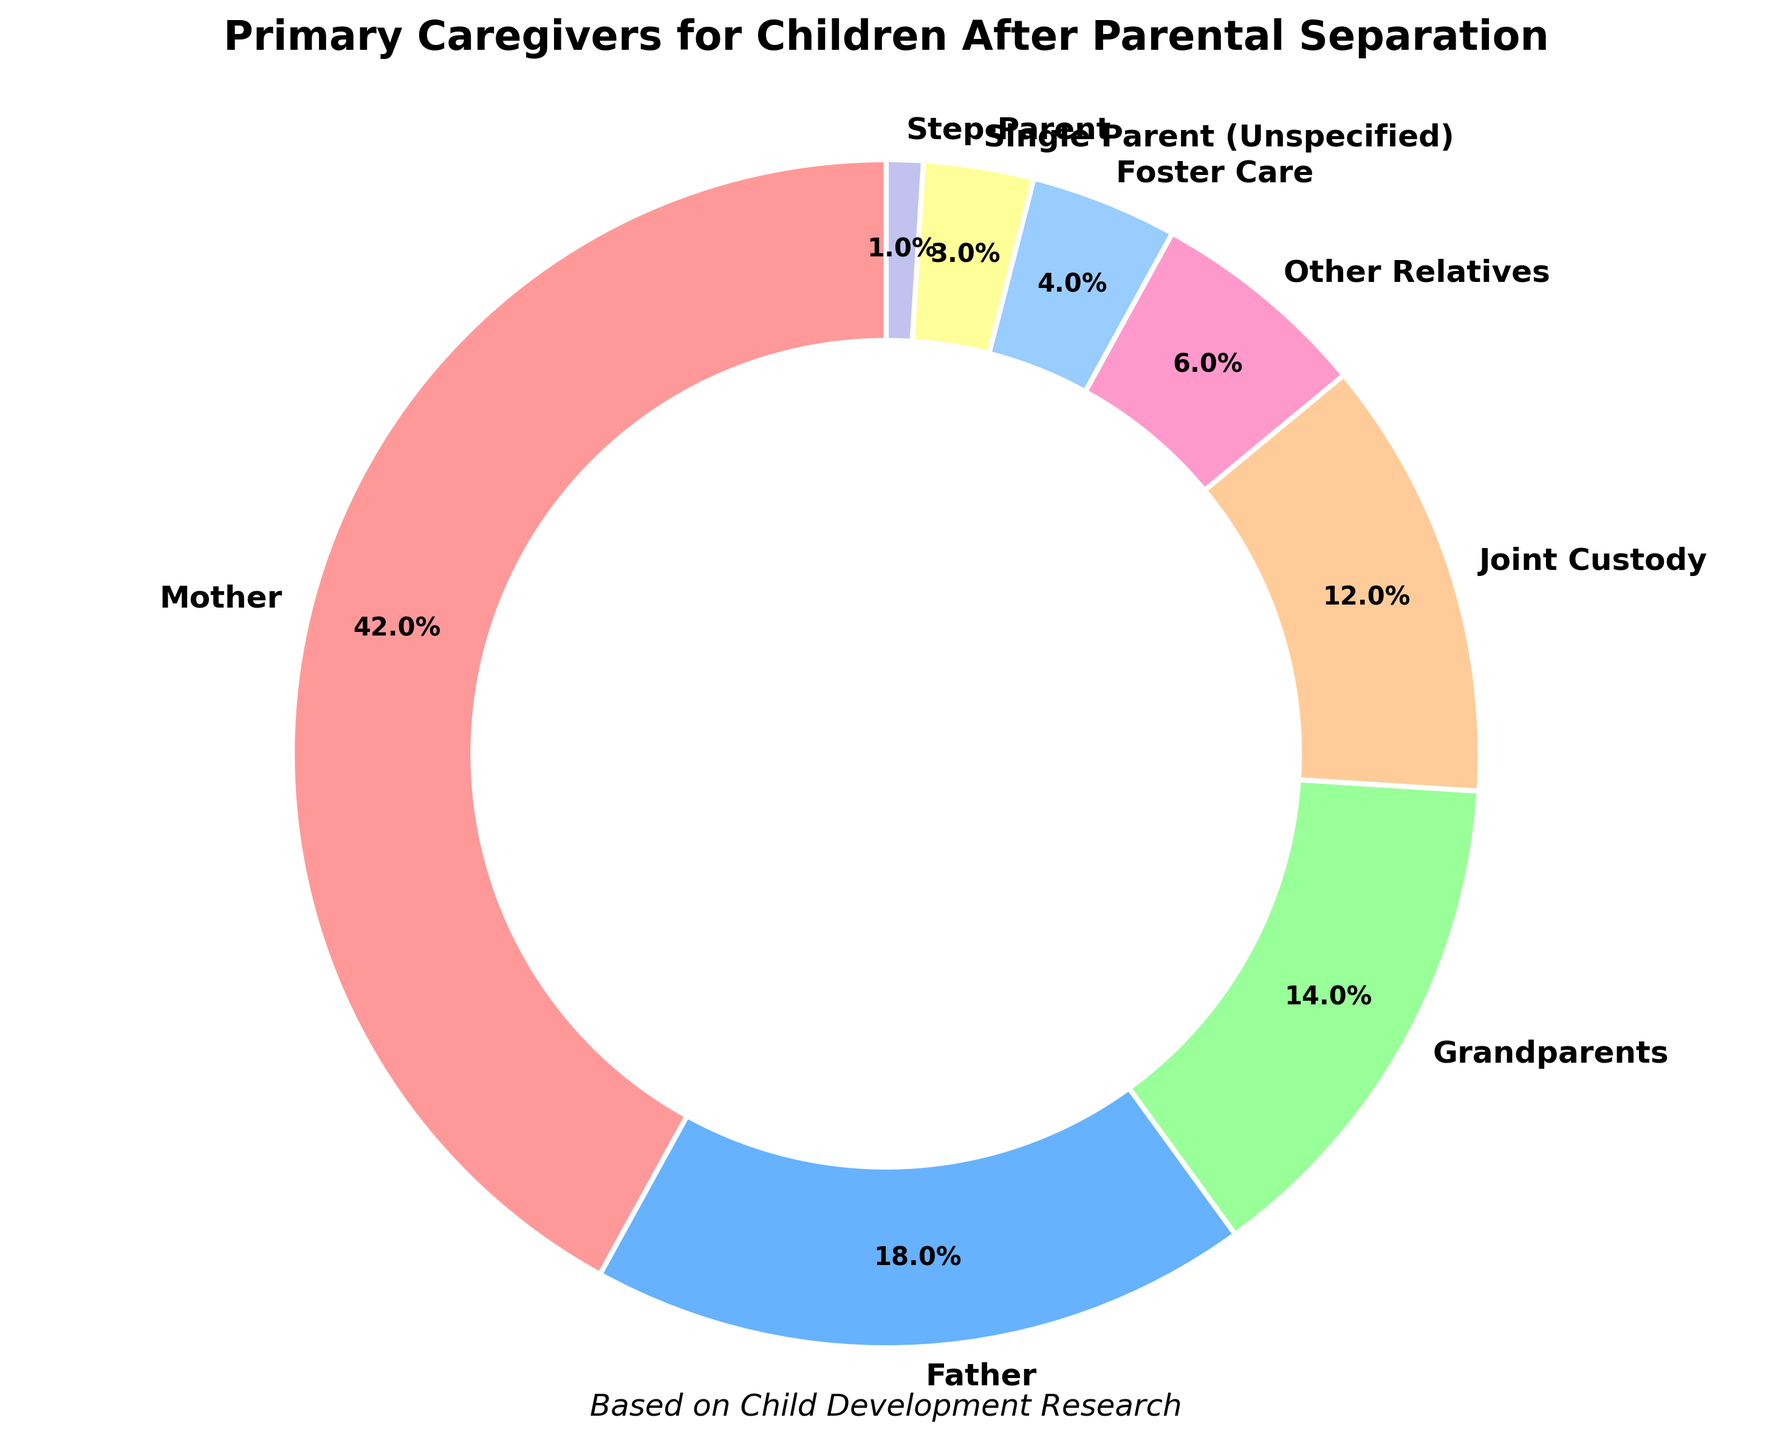What's the largest group of primary caregivers for children after parental separation? The wedge corresponding to mothers is the largest in the pie chart, with a percentage of 42%.
Answer: Mothers Which group has the smallest representation in the pie chart? The smallest wedge in the pie chart is for step-parents, with a percentage of 1%.
Answer: Step-parents What is the combined percentage of grandparents and foster care as primary caregivers? Grandparents have 14% and foster care has 4%. Adding these together: 14% + 4% = 18%.
Answer: 18% Are there more children in joint custody or in foster care? The wedge for joint custody is larger, showing 12%, while foster care shows 4%. Thus, there are more children in joint custody.
Answer: Joint custody How many percentage points more do mothers represent as primary caregivers compared to fathers? Mothers represent 42% and fathers represent 18%. The difference is 42% - 18% = 24%.
Answer: 24 percentage points What's the total percentage of children living with relatives other than their parents (including grandparents, other relatives, and step-parents)? Grandparents: 14%, Other Relatives: 6%, Step-Parent: 1%. Adding these together: 14% + 6% + 1% = 21%.
Answer: 21% Which groups of primary caregivers have less representation than joint custody? Joint custody has 12%. The groups with less representation are other relatives (6%), foster care (4%), single parent unspecified (3%), and step-parent (1%).
Answer: Other relatives, foster care, single parent unspecified, step-parent What is the visual color representing grandparents as primary caregivers? The wedge representing grandparents is colored green in the pie chart.
Answer: Green Is the percentage of children in joint custody closer to the percentage of children living with other relatives or with fathers? Joint custody is 12%, other relatives are 6%, and fathers are 18%. 12% is closer to 18% than to 6%.
Answer: Fathers What percentage more do mothers contribute as primary caregivers compared to the sum of other relatives and foster care? Mothers: 42%, Other Relatives: 6%, Foster Care: 4%. Sum of other relatives and foster care: 6% + 4% = 10%. Difference: 42% - 10% = 32%.
Answer: 32% What is the proportional difference between single parent (unspecified) and parents (both mother and father combined)? Single parent (unspecified): 3%. Mother: 42%, Father: 18%. Combined: 42% + 18% = 60%. Difference: 60% - 3% = 57%.
Answer: 57% 